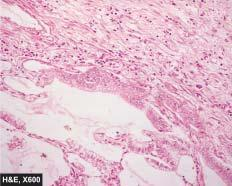re the alveolar walls lined by cuboidal to tall columnar and mucin-secreting tumour cells with papillary growth pattern?
Answer the question using a single word or phrase. Yes 